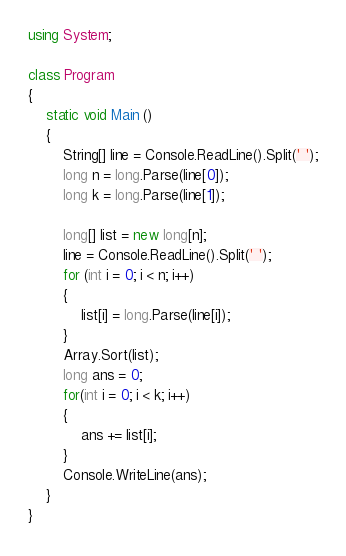Convert code to text. <code><loc_0><loc_0><loc_500><loc_500><_C#_>using System;

class Program
{
    static void Main () 
    {
        String[] line = Console.ReadLine().Split(' ');
        long n = long.Parse(line[0]);
        long k = long.Parse(line[1]);

        long[] list = new long[n];
        line = Console.ReadLine().Split(' ');
        for (int i = 0; i < n; i++)
        {
            list[i] = long.Parse(line[i]);
        }
        Array.Sort(list);
        long ans = 0;
        for(int i = 0; i < k; i++)
        {
            ans += list[i];
        }
        Console.WriteLine(ans);
    }
}</code> 